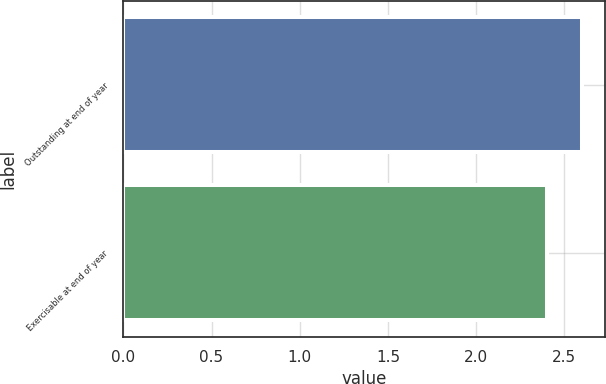Convert chart to OTSL. <chart><loc_0><loc_0><loc_500><loc_500><bar_chart><fcel>Outstanding at end of year<fcel>Exercisable at end of year<nl><fcel>2.6<fcel>2.4<nl></chart> 